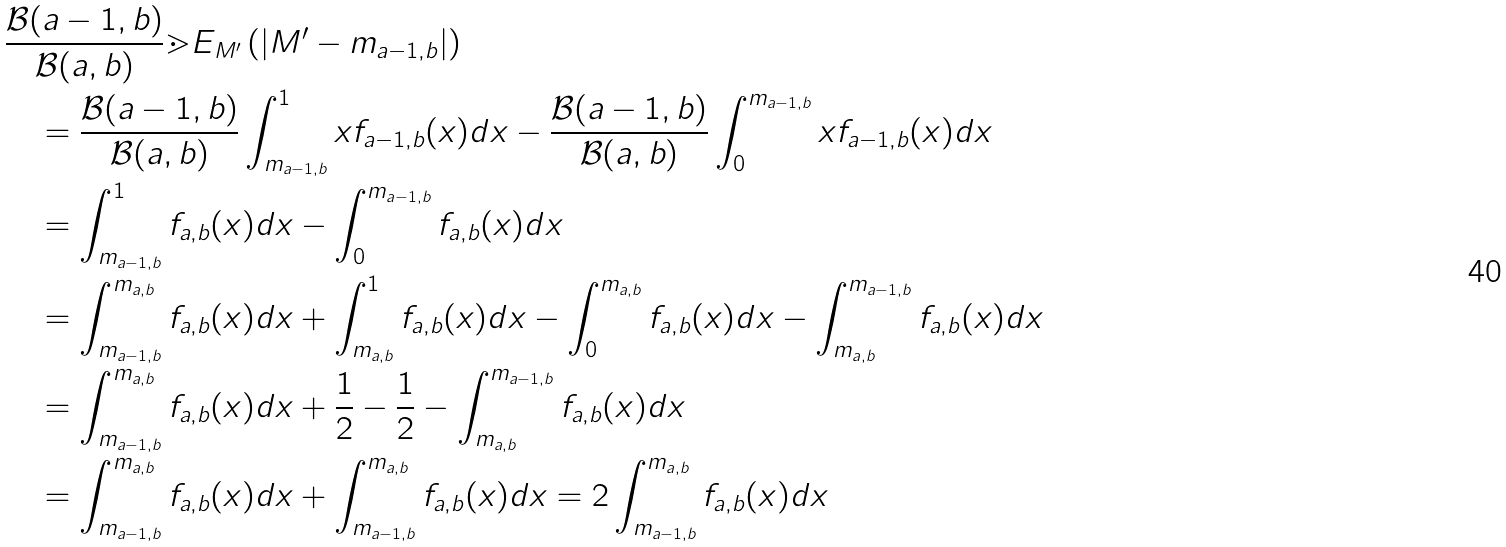Convert formula to latex. <formula><loc_0><loc_0><loc_500><loc_500>& \frac { \mathcal { B } ( a - 1 , b ) } { \mathcal { B } ( a , b ) } \mathbb { m } { E } _ { M ^ { \prime } } \left ( | M ^ { \prime } - m _ { a - 1 , b } | \right ) \\ & \quad = \frac { \mathcal { B } ( a - 1 , b ) } { \mathcal { B } ( a , b ) } \int _ { m _ { a - 1 , b } } ^ { 1 } x f _ { a - 1 , b } ( x ) d x - \frac { \mathcal { B } ( a - 1 , b ) } { \mathcal { B } ( a , b ) } \int _ { 0 } ^ { m _ { a - 1 , b } } x f _ { a - 1 , b } ( x ) d x \\ & \quad = \int _ { m _ { a - 1 , b } } ^ { 1 } f _ { a , b } ( x ) d x - \int _ { 0 } ^ { m _ { a - 1 , b } } f _ { a , b } ( x ) d x \\ & \quad = \int _ { m _ { a - 1 , b } } ^ { m _ { a , b } } f _ { a , b } ( x ) d x + \int _ { m _ { a , b } } ^ { 1 } f _ { a , b } ( x ) d x - \int _ { 0 } ^ { m _ { a , b } } f _ { a , b } ( x ) d x - \int _ { m _ { a , b } } ^ { m _ { a - 1 , b } } f _ { a , b } ( x ) d x \\ & \quad = \int _ { m _ { a - 1 , b } } ^ { m _ { a , b } } f _ { a , b } ( x ) d x + \frac { 1 } { 2 } - \frac { 1 } { 2 } - \int _ { m _ { a , b } } ^ { m _ { a - 1 , b } } f _ { a , b } ( x ) d x \\ & \quad = \int _ { m _ { a - 1 , b } } ^ { m _ { a , b } } f _ { a , b } ( x ) d x + \int _ { m _ { a - 1 , b } } ^ { m _ { a , b } } f _ { a , b } ( x ) d x = 2 \int _ { m _ { a - 1 , b } } ^ { m _ { a , b } } f _ { a , b } ( x ) d x</formula> 